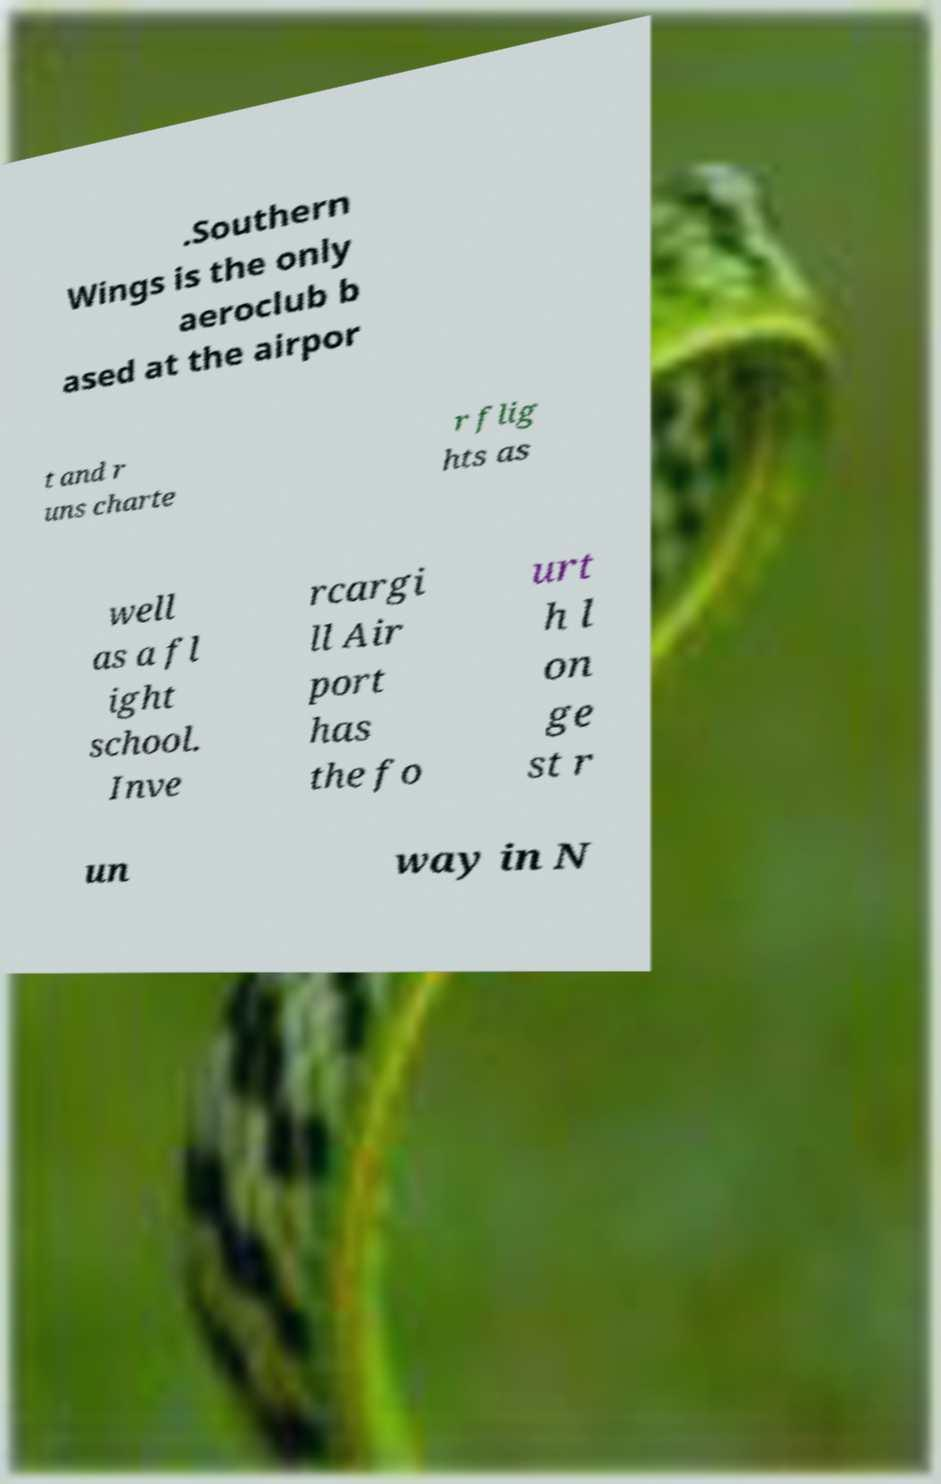Can you accurately transcribe the text from the provided image for me? .Southern Wings is the only aeroclub b ased at the airpor t and r uns charte r flig hts as well as a fl ight school. Inve rcargi ll Air port has the fo urt h l on ge st r un way in N 